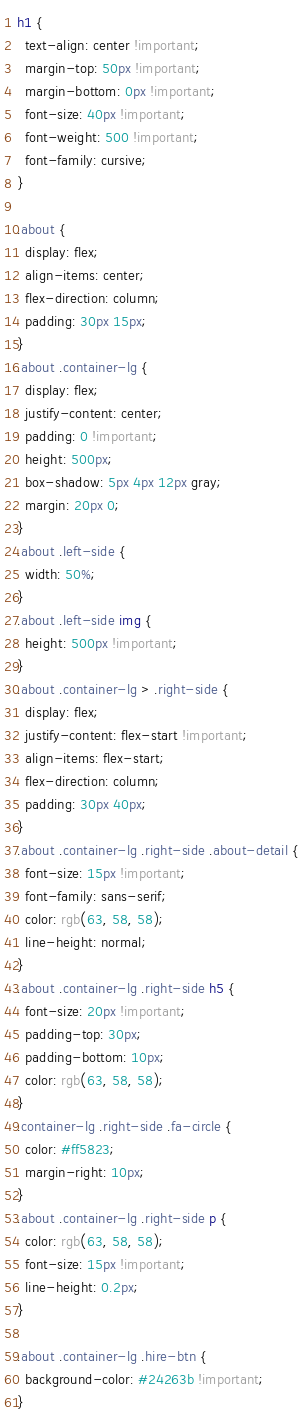<code> <loc_0><loc_0><loc_500><loc_500><_CSS_>h1 {
  text-align: center !important;
  margin-top: 50px !important;
  margin-bottom: 0px !important;
  font-size: 40px !important;
  font-weight: 500 !important;
  font-family: cursive;
}

.about {
  display: flex;
  align-items: center;
  flex-direction: column;
  padding: 30px 15px;
}
.about .container-lg {
  display: flex;
  justify-content: center;
  padding: 0 !important;
  height: 500px;
  box-shadow: 5px 4px 12px gray;
  margin: 20px 0;
}
.about .left-side {
  width: 50%;
}
.about .left-side img {
  height: 500px !important;
}
.about .container-lg > .right-side {
  display: flex;
  justify-content: flex-start !important;
  align-items: flex-start;
  flex-direction: column;
  padding: 30px 40px;
}
.about .container-lg .right-side .about-detail {
  font-size: 15px !important;
  font-family: sans-serif;
  color: rgb(63, 58, 58);
  line-height: normal;
}
.about .container-lg .right-side h5 {
  font-size: 20px !important;
  padding-top: 30px;
  padding-bottom: 10px;
  color: rgb(63, 58, 58);
}
.container-lg .right-side .fa-circle {
  color: #ff5823;
  margin-right: 10px;
}
.about .container-lg .right-side p {
  color: rgb(63, 58, 58);
  font-size: 15px !important;
  line-height: 0.2px;
}

.about .container-lg .hire-btn {
  background-color: #24263b !important;
}</code> 